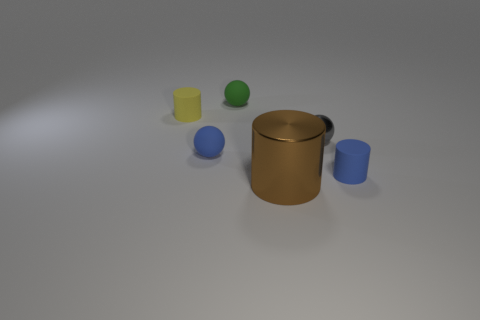Subtract all matte balls. How many balls are left? 1 Add 1 tiny blue rubber balls. How many objects exist? 7 Add 6 blue cylinders. How many blue cylinders are left? 7 Add 3 rubber cylinders. How many rubber cylinders exist? 5 Subtract 0 yellow balls. How many objects are left? 6 Subtract all blue rubber cylinders. Subtract all metallic objects. How many objects are left? 3 